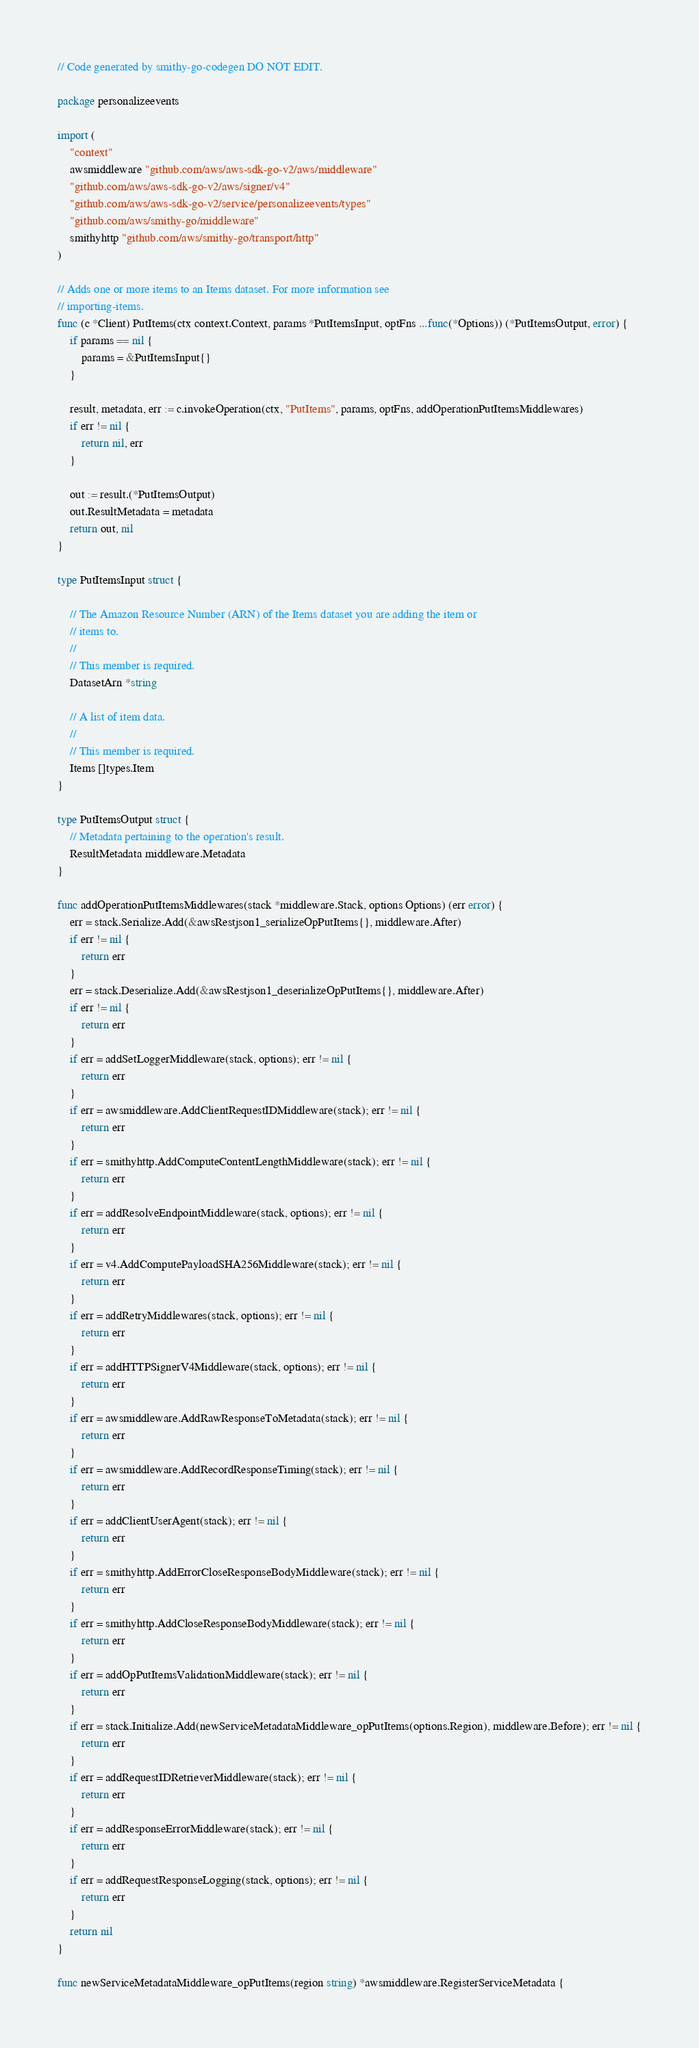Convert code to text. <code><loc_0><loc_0><loc_500><loc_500><_Go_>// Code generated by smithy-go-codegen DO NOT EDIT.

package personalizeevents

import (
	"context"
	awsmiddleware "github.com/aws/aws-sdk-go-v2/aws/middleware"
	"github.com/aws/aws-sdk-go-v2/aws/signer/v4"
	"github.com/aws/aws-sdk-go-v2/service/personalizeevents/types"
	"github.com/aws/smithy-go/middleware"
	smithyhttp "github.com/aws/smithy-go/transport/http"
)

// Adds one or more items to an Items dataset. For more information see
// importing-items.
func (c *Client) PutItems(ctx context.Context, params *PutItemsInput, optFns ...func(*Options)) (*PutItemsOutput, error) {
	if params == nil {
		params = &PutItemsInput{}
	}

	result, metadata, err := c.invokeOperation(ctx, "PutItems", params, optFns, addOperationPutItemsMiddlewares)
	if err != nil {
		return nil, err
	}

	out := result.(*PutItemsOutput)
	out.ResultMetadata = metadata
	return out, nil
}

type PutItemsInput struct {

	// The Amazon Resource Number (ARN) of the Items dataset you are adding the item or
	// items to.
	//
	// This member is required.
	DatasetArn *string

	// A list of item data.
	//
	// This member is required.
	Items []types.Item
}

type PutItemsOutput struct {
	// Metadata pertaining to the operation's result.
	ResultMetadata middleware.Metadata
}

func addOperationPutItemsMiddlewares(stack *middleware.Stack, options Options) (err error) {
	err = stack.Serialize.Add(&awsRestjson1_serializeOpPutItems{}, middleware.After)
	if err != nil {
		return err
	}
	err = stack.Deserialize.Add(&awsRestjson1_deserializeOpPutItems{}, middleware.After)
	if err != nil {
		return err
	}
	if err = addSetLoggerMiddleware(stack, options); err != nil {
		return err
	}
	if err = awsmiddleware.AddClientRequestIDMiddleware(stack); err != nil {
		return err
	}
	if err = smithyhttp.AddComputeContentLengthMiddleware(stack); err != nil {
		return err
	}
	if err = addResolveEndpointMiddleware(stack, options); err != nil {
		return err
	}
	if err = v4.AddComputePayloadSHA256Middleware(stack); err != nil {
		return err
	}
	if err = addRetryMiddlewares(stack, options); err != nil {
		return err
	}
	if err = addHTTPSignerV4Middleware(stack, options); err != nil {
		return err
	}
	if err = awsmiddleware.AddRawResponseToMetadata(stack); err != nil {
		return err
	}
	if err = awsmiddleware.AddRecordResponseTiming(stack); err != nil {
		return err
	}
	if err = addClientUserAgent(stack); err != nil {
		return err
	}
	if err = smithyhttp.AddErrorCloseResponseBodyMiddleware(stack); err != nil {
		return err
	}
	if err = smithyhttp.AddCloseResponseBodyMiddleware(stack); err != nil {
		return err
	}
	if err = addOpPutItemsValidationMiddleware(stack); err != nil {
		return err
	}
	if err = stack.Initialize.Add(newServiceMetadataMiddleware_opPutItems(options.Region), middleware.Before); err != nil {
		return err
	}
	if err = addRequestIDRetrieverMiddleware(stack); err != nil {
		return err
	}
	if err = addResponseErrorMiddleware(stack); err != nil {
		return err
	}
	if err = addRequestResponseLogging(stack, options); err != nil {
		return err
	}
	return nil
}

func newServiceMetadataMiddleware_opPutItems(region string) *awsmiddleware.RegisterServiceMetadata {</code> 